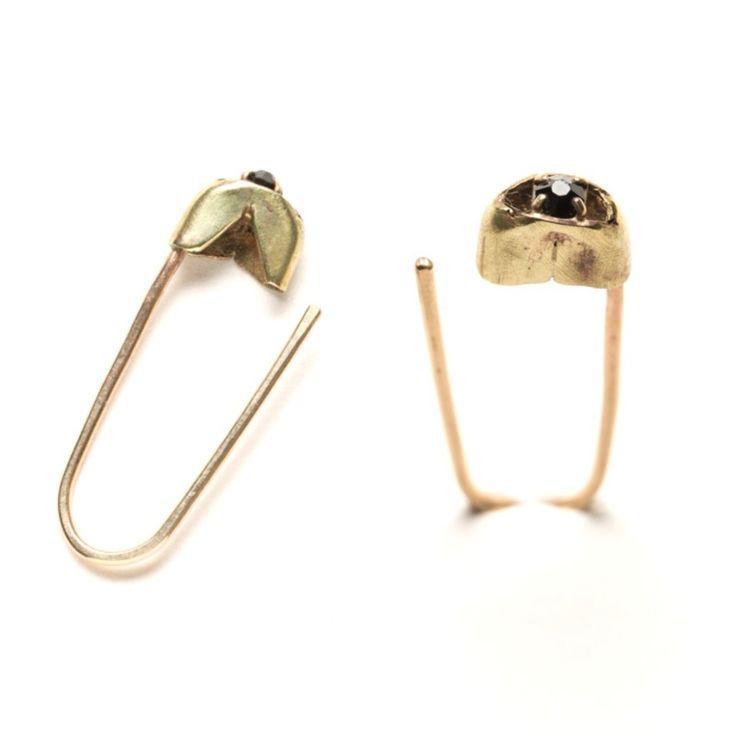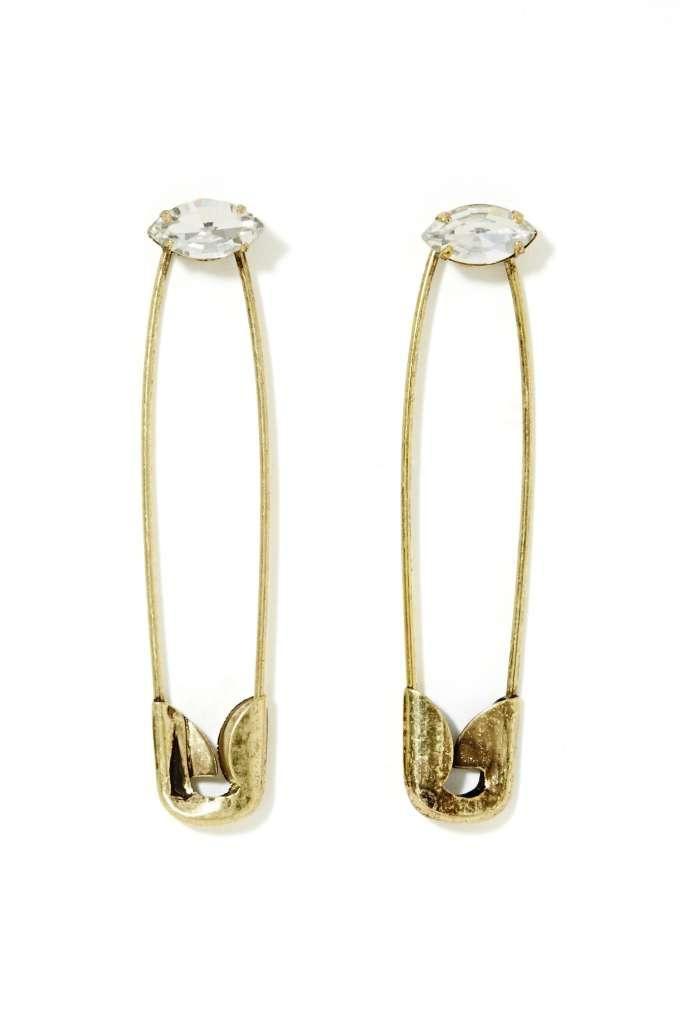The first image is the image on the left, the second image is the image on the right. For the images shown, is this caption "there are 4 safety pins in the image pair" true? Answer yes or no. Yes. The first image is the image on the left, the second image is the image on the right. Evaluate the accuracy of this statement regarding the images: "At least one image includes a pair of closed, unembellished gold safety pins displayed with the clasp end downward.". Is it true? Answer yes or no. No. 